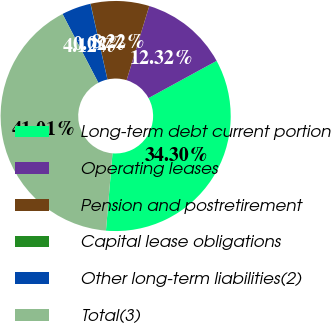<chart> <loc_0><loc_0><loc_500><loc_500><pie_chart><fcel>Long-term debt current portion<fcel>Operating leases<fcel>Pension and postretirement<fcel>Capital lease obligations<fcel>Other long-term liabilities(2)<fcel>Total(3)<nl><fcel>34.3%<fcel>12.32%<fcel>8.22%<fcel>0.02%<fcel>4.12%<fcel>41.01%<nl></chart> 